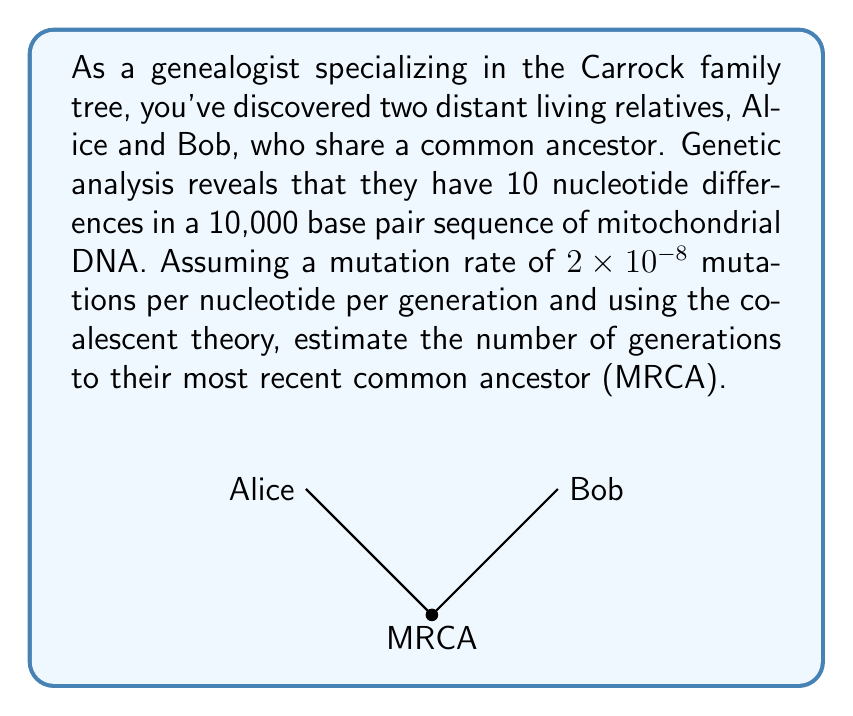Could you help me with this problem? To estimate the time to the most recent common ancestor (MRCA) using coalescent theory, we'll follow these steps:

1) First, we need to calculate the genetic distance between Alice and Bob. This is given by:

   $d = \frac{\text{number of differences}}{\text{total sequence length}}$

   $d = \frac{10}{10,000} = 0.001$

2) In coalescent theory, the expected time to the MRCA (T) is related to the genetic distance (d) and the mutation rate (μ) by the formula:

   $E[T] = \frac{d}{2\mu}$

   Where T is measured in generations.

3) We're given that the mutation rate μ = $2 \times 10^{-8}$ mutations per nucleotide per generation.

4) Substituting these values into the formula:

   $E[T] = \frac{0.001}{2 \times (2 \times 10^{-8})}$

5) Simplifying:

   $E[T] = \frac{0.001}{4 \times 10^{-8}} = \frac{1 \times 10^{-3}}{4 \times 10^{-8}} = 25,000$

Therefore, the estimated number of generations to the MRCA is 25,000.
Answer: 25,000 generations 